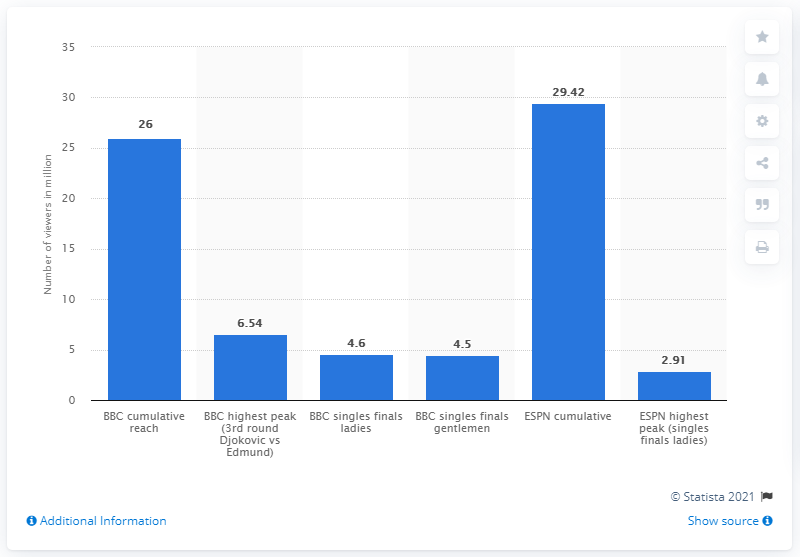List a handful of essential elements in this visual. The number of viewers who watched the Wimbledon Championships on BBC in 2018 was 26. The number of viewers who watched the Wimbledon Championships on ESPN in 2018 was 29.42. The viewership for the ESPN singles finals was 2.91 million. 